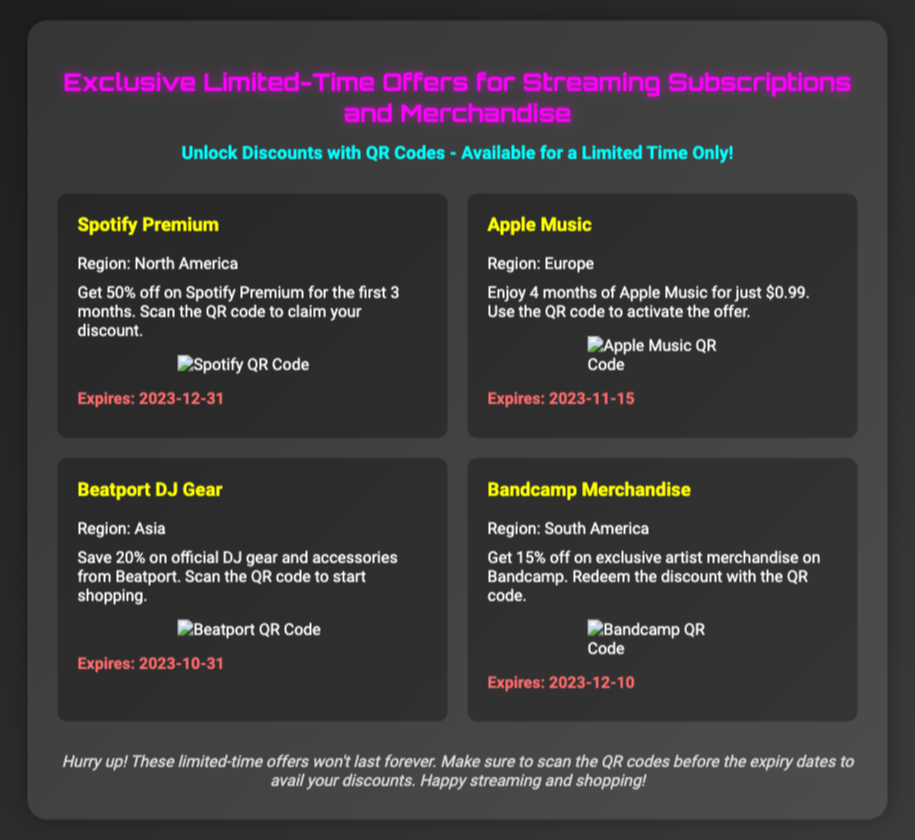what is the discount for Spotify Premium? The document states that there is a 50% off discount for Spotify Premium for the first 3 months.
Answer: 50% off when does the Apple Music offer expire? The expiry date for the Apple Music offer is mentioned in the document as 2023-11-15.
Answer: 2023-11-15 which region is the Beatport DJ Gear offer for? The offer for Beatport DJ Gear specifies that it is valid for the Asia region.
Answer: Asia how much can you save on official DJ gear from Beatport? The document indicates a 20% savings on official DJ gear and accessories.
Answer: 20% what is the duration of the Apple Music offer? The document specifies that the offer includes 4 months of Apple Music for just $0.99.
Answer: 4 months what is the discount percentage for Bandcamp merchandise? According to the document, the discount for Bandcamp merchandise is 15%.
Answer: 15% which offer expires on 2023-12-10? The discount for Bandcamp merchandise is the only offer that expires on this date.
Answer: Bandcamp Merchandise what do you need to do to activate the Apple Music offer? The document mentions that you need to use the QR code to activate the Apple Music offer.
Answer: Scan the QR code what is the title of the ticket? The title of the ticket is stated in the document.
Answer: Exclusive Limited-Time Offers for Streaming Subscriptions and Merchandise 